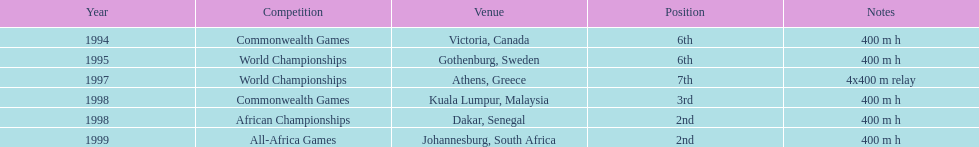What is the total count of titles won by ken harden? 6. 